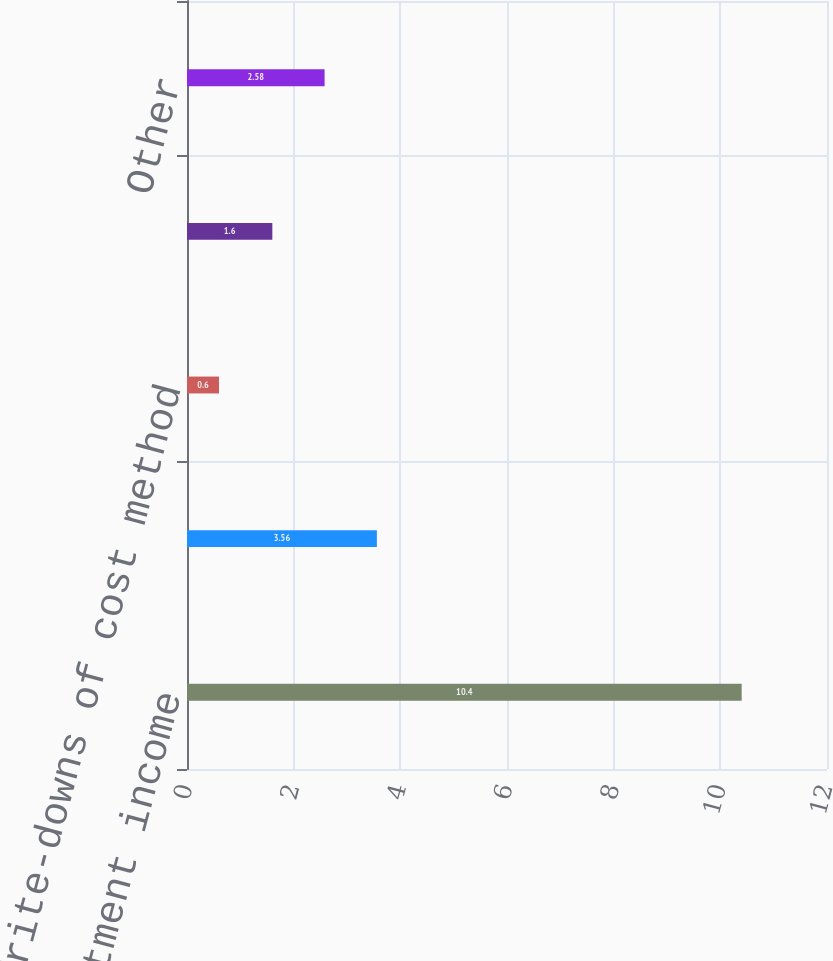Convert chart to OTSL. <chart><loc_0><loc_0><loc_500><loc_500><bar_chart><fcel>Interest and investment income<fcel>Gains (losses) on foreign<fcel>Write-downs of cost method<fcel>Realized gains on sales of<fcel>Other<nl><fcel>10.4<fcel>3.56<fcel>0.6<fcel>1.6<fcel>2.58<nl></chart> 